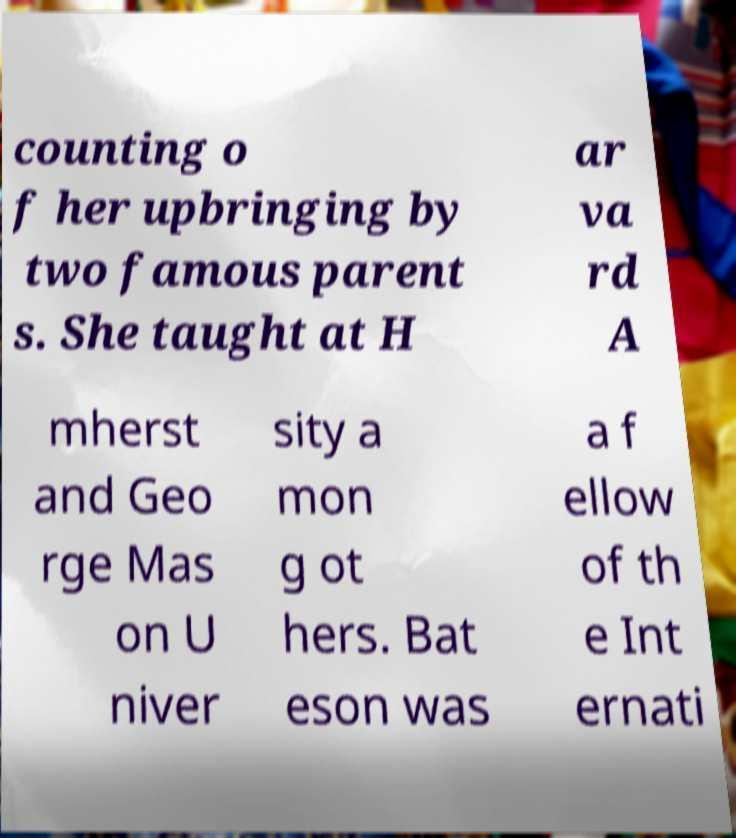Could you assist in decoding the text presented in this image and type it out clearly? counting o f her upbringing by two famous parent s. She taught at H ar va rd A mherst and Geo rge Mas on U niver sity a mon g ot hers. Bat eson was a f ellow of th e Int ernati 